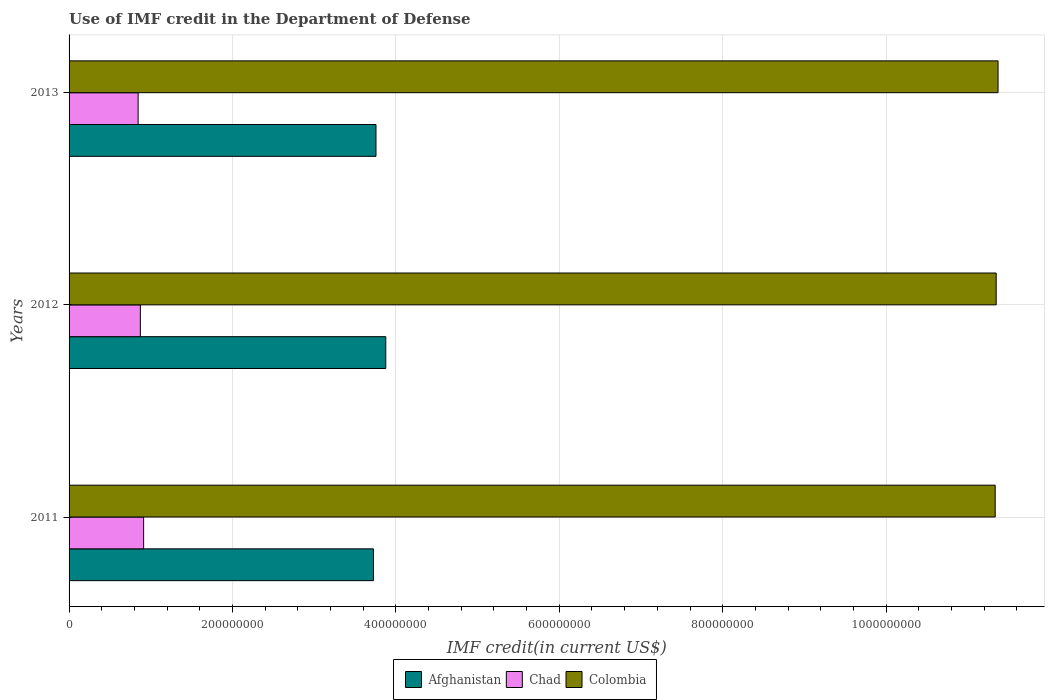How many different coloured bars are there?
Keep it short and to the point. 3. How many groups of bars are there?
Your answer should be very brief. 3. How many bars are there on the 3rd tick from the top?
Offer a terse response. 3. How many bars are there on the 2nd tick from the bottom?
Offer a terse response. 3. What is the label of the 3rd group of bars from the top?
Offer a terse response. 2011. What is the IMF credit in the Department of Defense in Afghanistan in 2011?
Your response must be concise. 3.73e+08. Across all years, what is the maximum IMF credit in the Department of Defense in Colombia?
Provide a short and direct response. 1.14e+09. Across all years, what is the minimum IMF credit in the Department of Defense in Afghanistan?
Your answer should be very brief. 3.73e+08. In which year was the IMF credit in the Department of Defense in Chad minimum?
Ensure brevity in your answer.  2013. What is the total IMF credit in the Department of Defense in Colombia in the graph?
Give a very brief answer. 3.41e+09. What is the difference between the IMF credit in the Department of Defense in Colombia in 2011 and that in 2012?
Make the answer very short. -1.22e+06. What is the difference between the IMF credit in the Department of Defense in Afghanistan in 2011 and the IMF credit in the Department of Defense in Chad in 2012?
Provide a succinct answer. 2.85e+08. What is the average IMF credit in the Department of Defense in Chad per year?
Offer a very short reply. 8.77e+07. In the year 2013, what is the difference between the IMF credit in the Department of Defense in Chad and IMF credit in the Department of Defense in Afghanistan?
Your answer should be compact. -2.91e+08. What is the ratio of the IMF credit in the Department of Defense in Colombia in 2011 to that in 2013?
Offer a very short reply. 1. What is the difference between the highest and the second highest IMF credit in the Department of Defense in Afghanistan?
Offer a very short reply. 1.20e+07. What is the difference between the highest and the lowest IMF credit in the Department of Defense in Afghanistan?
Offer a terse response. 1.51e+07. In how many years, is the IMF credit in the Department of Defense in Colombia greater than the average IMF credit in the Department of Defense in Colombia taken over all years?
Your answer should be very brief. 1. Is the sum of the IMF credit in the Department of Defense in Afghanistan in 2011 and 2012 greater than the maximum IMF credit in the Department of Defense in Chad across all years?
Give a very brief answer. Yes. What does the 2nd bar from the top in 2012 represents?
Give a very brief answer. Chad. What does the 3rd bar from the bottom in 2011 represents?
Offer a terse response. Colombia. How many bars are there?
Offer a very short reply. 9. Are all the bars in the graph horizontal?
Your response must be concise. Yes. How many years are there in the graph?
Give a very brief answer. 3. What is the difference between two consecutive major ticks on the X-axis?
Provide a short and direct response. 2.00e+08. Does the graph contain any zero values?
Make the answer very short. No. Does the graph contain grids?
Your answer should be very brief. Yes. How many legend labels are there?
Your answer should be very brief. 3. What is the title of the graph?
Keep it short and to the point. Use of IMF credit in the Department of Defense. What is the label or title of the X-axis?
Give a very brief answer. IMF credit(in current US$). What is the label or title of the Y-axis?
Your answer should be very brief. Years. What is the IMF credit(in current US$) of Afghanistan in 2011?
Give a very brief answer. 3.73e+08. What is the IMF credit(in current US$) in Chad in 2011?
Make the answer very short. 9.13e+07. What is the IMF credit(in current US$) in Colombia in 2011?
Your answer should be compact. 1.13e+09. What is the IMF credit(in current US$) in Afghanistan in 2012?
Offer a very short reply. 3.88e+08. What is the IMF credit(in current US$) of Chad in 2012?
Your response must be concise. 8.72e+07. What is the IMF credit(in current US$) of Colombia in 2012?
Your answer should be very brief. 1.13e+09. What is the IMF credit(in current US$) of Afghanistan in 2013?
Your response must be concise. 3.76e+08. What is the IMF credit(in current US$) of Chad in 2013?
Keep it short and to the point. 8.45e+07. What is the IMF credit(in current US$) of Colombia in 2013?
Make the answer very short. 1.14e+09. Across all years, what is the maximum IMF credit(in current US$) in Afghanistan?
Your response must be concise. 3.88e+08. Across all years, what is the maximum IMF credit(in current US$) of Chad?
Offer a very short reply. 9.13e+07. Across all years, what is the maximum IMF credit(in current US$) of Colombia?
Your response must be concise. 1.14e+09. Across all years, what is the minimum IMF credit(in current US$) in Afghanistan?
Give a very brief answer. 3.73e+08. Across all years, what is the minimum IMF credit(in current US$) in Chad?
Provide a succinct answer. 8.45e+07. Across all years, what is the minimum IMF credit(in current US$) of Colombia?
Make the answer very short. 1.13e+09. What is the total IMF credit(in current US$) in Afghanistan in the graph?
Offer a terse response. 1.14e+09. What is the total IMF credit(in current US$) in Chad in the graph?
Provide a short and direct response. 2.63e+08. What is the total IMF credit(in current US$) in Colombia in the graph?
Provide a succinct answer. 3.41e+09. What is the difference between the IMF credit(in current US$) of Afghanistan in 2011 and that in 2012?
Your response must be concise. -1.51e+07. What is the difference between the IMF credit(in current US$) of Chad in 2011 and that in 2012?
Keep it short and to the point. 4.02e+06. What is the difference between the IMF credit(in current US$) of Colombia in 2011 and that in 2012?
Ensure brevity in your answer.  -1.22e+06. What is the difference between the IMF credit(in current US$) in Afghanistan in 2011 and that in 2013?
Offer a terse response. -3.09e+06. What is the difference between the IMF credit(in current US$) in Chad in 2011 and that in 2013?
Give a very brief answer. 6.74e+06. What is the difference between the IMF credit(in current US$) in Colombia in 2011 and that in 2013?
Ensure brevity in your answer.  -3.49e+06. What is the difference between the IMF credit(in current US$) in Afghanistan in 2012 and that in 2013?
Make the answer very short. 1.20e+07. What is the difference between the IMF credit(in current US$) in Chad in 2012 and that in 2013?
Your answer should be compact. 2.72e+06. What is the difference between the IMF credit(in current US$) of Colombia in 2012 and that in 2013?
Keep it short and to the point. -2.27e+06. What is the difference between the IMF credit(in current US$) in Afghanistan in 2011 and the IMF credit(in current US$) in Chad in 2012?
Provide a short and direct response. 2.85e+08. What is the difference between the IMF credit(in current US$) in Afghanistan in 2011 and the IMF credit(in current US$) in Colombia in 2012?
Keep it short and to the point. -7.62e+08. What is the difference between the IMF credit(in current US$) in Chad in 2011 and the IMF credit(in current US$) in Colombia in 2012?
Offer a very short reply. -1.04e+09. What is the difference between the IMF credit(in current US$) in Afghanistan in 2011 and the IMF credit(in current US$) in Chad in 2013?
Provide a short and direct response. 2.88e+08. What is the difference between the IMF credit(in current US$) in Afghanistan in 2011 and the IMF credit(in current US$) in Colombia in 2013?
Your response must be concise. -7.64e+08. What is the difference between the IMF credit(in current US$) of Chad in 2011 and the IMF credit(in current US$) of Colombia in 2013?
Give a very brief answer. -1.05e+09. What is the difference between the IMF credit(in current US$) of Afghanistan in 2012 and the IMF credit(in current US$) of Chad in 2013?
Ensure brevity in your answer.  3.03e+08. What is the difference between the IMF credit(in current US$) of Afghanistan in 2012 and the IMF credit(in current US$) of Colombia in 2013?
Give a very brief answer. -7.49e+08. What is the difference between the IMF credit(in current US$) of Chad in 2012 and the IMF credit(in current US$) of Colombia in 2013?
Your response must be concise. -1.05e+09. What is the average IMF credit(in current US$) in Afghanistan per year?
Provide a short and direct response. 3.79e+08. What is the average IMF credit(in current US$) of Chad per year?
Give a very brief answer. 8.77e+07. What is the average IMF credit(in current US$) in Colombia per year?
Provide a short and direct response. 1.14e+09. In the year 2011, what is the difference between the IMF credit(in current US$) of Afghanistan and IMF credit(in current US$) of Chad?
Make the answer very short. 2.81e+08. In the year 2011, what is the difference between the IMF credit(in current US$) in Afghanistan and IMF credit(in current US$) in Colombia?
Make the answer very short. -7.61e+08. In the year 2011, what is the difference between the IMF credit(in current US$) in Chad and IMF credit(in current US$) in Colombia?
Keep it short and to the point. -1.04e+09. In the year 2012, what is the difference between the IMF credit(in current US$) in Afghanistan and IMF credit(in current US$) in Chad?
Ensure brevity in your answer.  3.00e+08. In the year 2012, what is the difference between the IMF credit(in current US$) in Afghanistan and IMF credit(in current US$) in Colombia?
Keep it short and to the point. -7.47e+08. In the year 2012, what is the difference between the IMF credit(in current US$) in Chad and IMF credit(in current US$) in Colombia?
Your answer should be very brief. -1.05e+09. In the year 2013, what is the difference between the IMF credit(in current US$) in Afghanistan and IMF credit(in current US$) in Chad?
Your response must be concise. 2.91e+08. In the year 2013, what is the difference between the IMF credit(in current US$) in Afghanistan and IMF credit(in current US$) in Colombia?
Offer a very short reply. -7.61e+08. In the year 2013, what is the difference between the IMF credit(in current US$) of Chad and IMF credit(in current US$) of Colombia?
Provide a short and direct response. -1.05e+09. What is the ratio of the IMF credit(in current US$) of Afghanistan in 2011 to that in 2012?
Make the answer very short. 0.96. What is the ratio of the IMF credit(in current US$) in Chad in 2011 to that in 2012?
Ensure brevity in your answer.  1.05. What is the ratio of the IMF credit(in current US$) of Colombia in 2011 to that in 2012?
Your answer should be compact. 1. What is the ratio of the IMF credit(in current US$) in Afghanistan in 2011 to that in 2013?
Ensure brevity in your answer.  0.99. What is the ratio of the IMF credit(in current US$) in Chad in 2011 to that in 2013?
Provide a succinct answer. 1.08. What is the ratio of the IMF credit(in current US$) of Afghanistan in 2012 to that in 2013?
Give a very brief answer. 1.03. What is the ratio of the IMF credit(in current US$) in Chad in 2012 to that in 2013?
Provide a succinct answer. 1.03. What is the ratio of the IMF credit(in current US$) of Colombia in 2012 to that in 2013?
Your answer should be very brief. 1. What is the difference between the highest and the second highest IMF credit(in current US$) in Afghanistan?
Keep it short and to the point. 1.20e+07. What is the difference between the highest and the second highest IMF credit(in current US$) in Chad?
Keep it short and to the point. 4.02e+06. What is the difference between the highest and the second highest IMF credit(in current US$) of Colombia?
Provide a short and direct response. 2.27e+06. What is the difference between the highest and the lowest IMF credit(in current US$) of Afghanistan?
Keep it short and to the point. 1.51e+07. What is the difference between the highest and the lowest IMF credit(in current US$) of Chad?
Provide a short and direct response. 6.74e+06. What is the difference between the highest and the lowest IMF credit(in current US$) of Colombia?
Your response must be concise. 3.49e+06. 